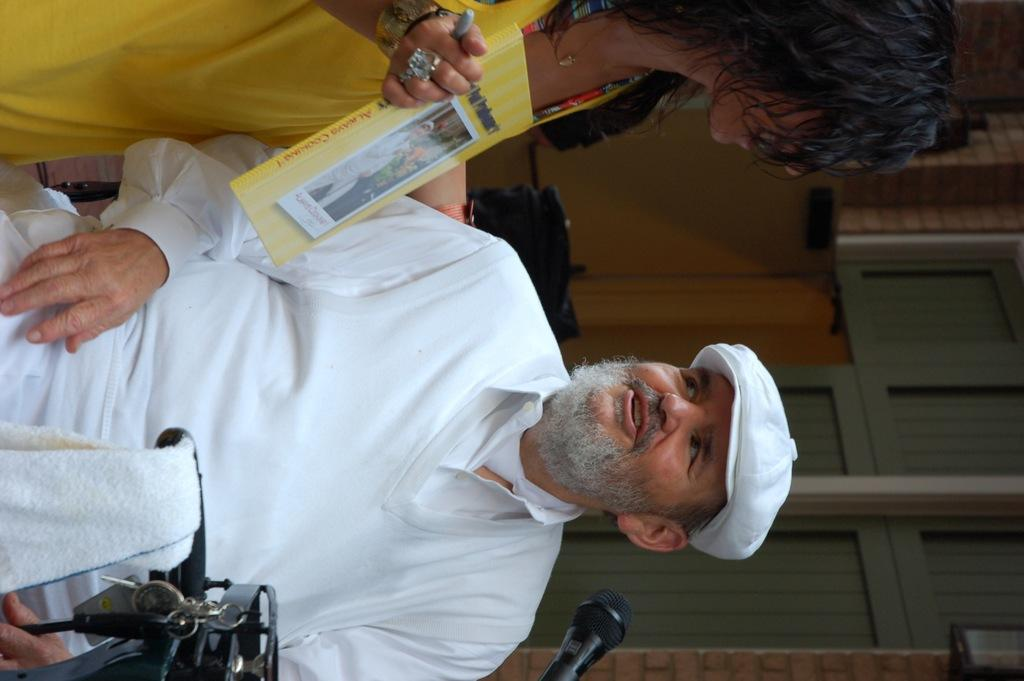Who is present in the image? There is a man and a woman in the image. What is the man wearing on his head? The man is wearing a cap. What object related to reading can be seen in the image? There is a book in the image. What item might be used for cleaning or wiping in the image? There is a napkin in the image. What object is typically used for amplifying sound? There is a microphone in the image. What type of jewelry is visible in the image? There is a finger ring, a neck chain, and a bracelet in the image. What is the background of the image made of? There is a wall in the image. What time of day is it in the image, and what flag is being displayed? The time of day is not mentioned in the image, and there is no flag present. What type of stove can be seen in the image? There is no stove present in the image. 